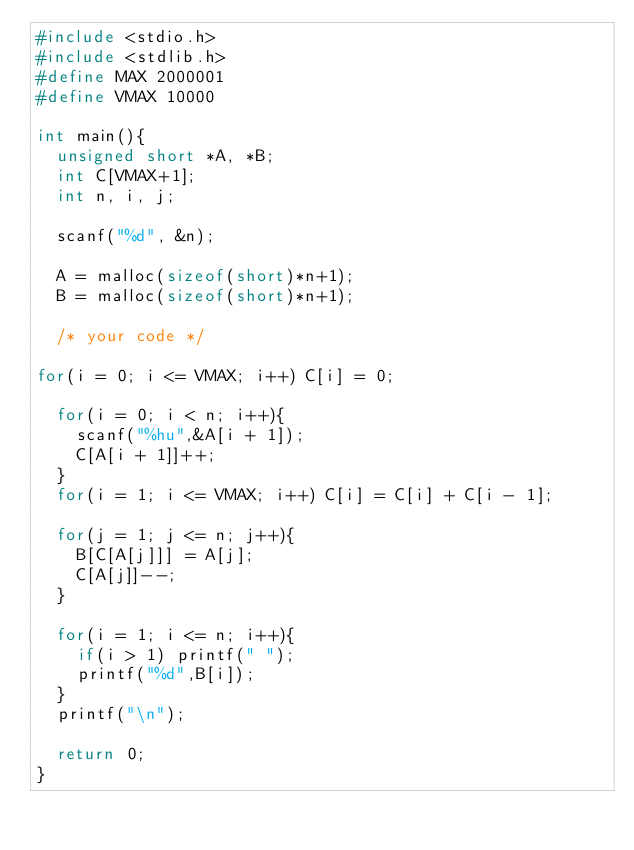<code> <loc_0><loc_0><loc_500><loc_500><_C_>#include <stdio.h>
#include <stdlib.h>
#define MAX 2000001
#define VMAX 10000

int main(){
  unsigned short *A, *B;
  int C[VMAX+1];
  int n, i, j;

  scanf("%d", &n);

  A = malloc(sizeof(short)*n+1);
  B = malloc(sizeof(short)*n+1);

  /* your code */

for(i = 0; i <= VMAX; i++) C[i] = 0;

  for(i = 0; i < n; i++){
    scanf("%hu",&A[i + 1]);
    C[A[i + 1]]++;
  }
  for(i = 1; i <= VMAX; i++) C[i] = C[i] + C[i - 1];

  for(j = 1; j <= n; j++){
    B[C[A[j]]] = A[j];
    C[A[j]]--;
  }

  for(i = 1; i <= n; i++){
    if(i > 1) printf(" ");
    printf("%d",B[i]);
  }
  printf("\n");

  return 0;
}


</code> 